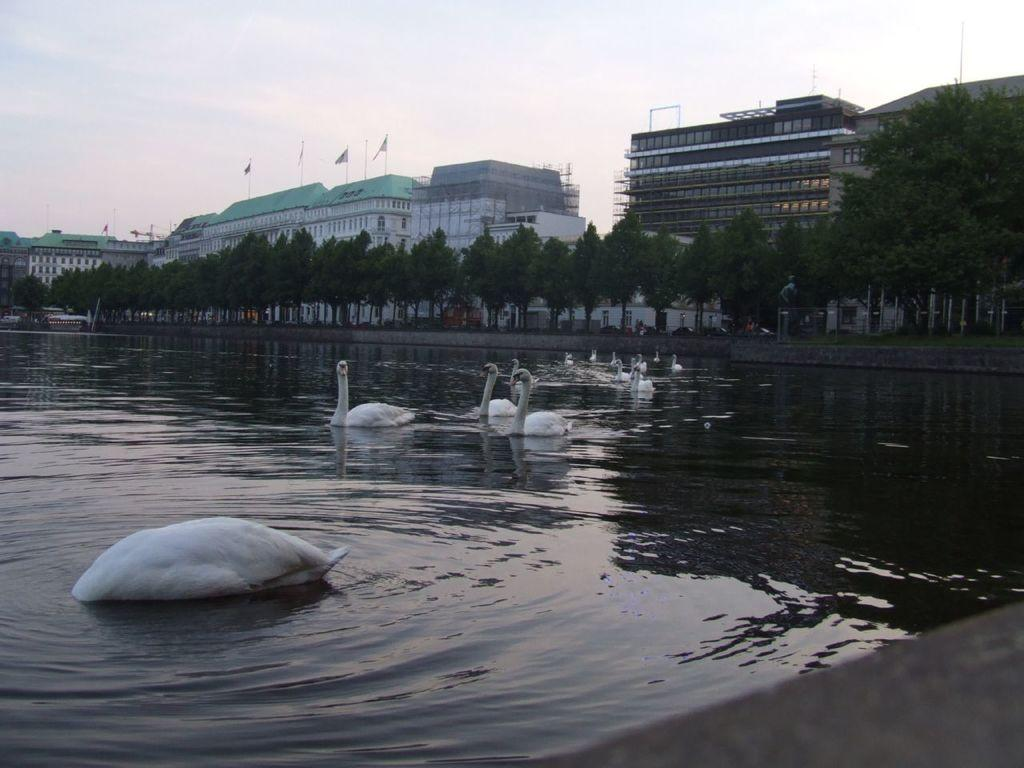What animals can be seen in the water body in the image? There is a group of swans in the water body in the image. What can be seen in the background of the image? Buildings, trees, and poles are visible in the background of the image. What is the condition of the sky in the image? The sky is cloudy in the image. What type of cherry is being used to decorate the poles in the image? There is no cherry present in the image, and the poles are not being decorated. What color is the gold paper used to wrap the swans in the image? There is no gold paper or wrapping present in the image; the swans are in their natural state. 